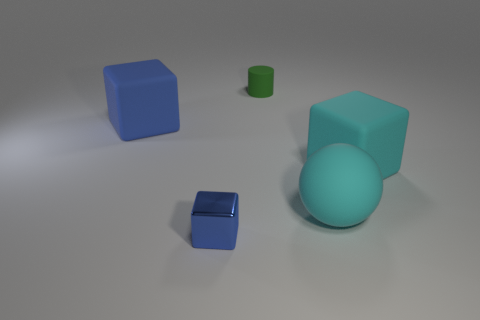Are there any other things that have the same material as the small blue thing?
Make the answer very short. No. Is the number of big cubes that are on the right side of the small metal object the same as the number of cyan rubber objects?
Provide a succinct answer. No. What material is the large cube in front of the object to the left of the small object that is in front of the cyan sphere?
Your answer should be compact. Rubber. There is a large sphere in front of the small green cylinder; what color is it?
Make the answer very short. Cyan. Is there anything else that has the same shape as the blue matte object?
Ensure brevity in your answer.  Yes. What size is the cube that is in front of the big rubber cube that is right of the green thing?
Offer a terse response. Small. Is the number of big balls to the left of the tiny rubber cylinder the same as the number of big cubes left of the large cyan matte sphere?
Make the answer very short. No. There is another block that is made of the same material as the large blue cube; what color is it?
Offer a very short reply. Cyan. Do the large ball and the blue block behind the metallic thing have the same material?
Your answer should be compact. Yes. What is the color of the rubber thing that is both on the right side of the cylinder and to the left of the big cyan block?
Offer a terse response. Cyan. 